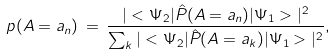<formula> <loc_0><loc_0><loc_500><loc_500>p ( A = a _ { n } ) \, = \, \frac { | < \Psi _ { 2 } | \hat { P } ( A = a _ { n } ) | \Psi _ { 1 } > | ^ { 2 } } { \sum _ { k } | < \Psi _ { 2 } | \hat { P } ( A = a _ { k } ) | \Psi _ { 1 } > | ^ { 2 } } ,</formula> 